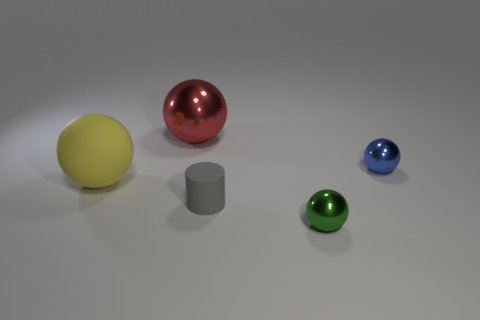Are there fewer green objects that are left of the large red thing than metal cylinders?
Provide a short and direct response. No. Are the small green sphere and the thing that is right of the green shiny ball made of the same material?
Provide a short and direct response. Yes. Are there any small shiny balls in front of the large yellow rubber ball behind the object that is in front of the small matte cylinder?
Provide a short and direct response. Yes. There is a ball that is made of the same material as the small gray thing; what is its color?
Keep it short and to the point. Yellow. There is a thing that is on the left side of the gray rubber cylinder and in front of the large red thing; how big is it?
Provide a succinct answer. Large. Is the number of large matte objects that are behind the small blue object less than the number of metallic objects on the right side of the small gray thing?
Provide a short and direct response. Yes. Is the material of the large object that is behind the large yellow ball the same as the small ball that is behind the small green ball?
Keep it short and to the point. Yes. The object that is both right of the small gray object and behind the small matte object has what shape?
Offer a very short reply. Sphere. What is the material of the sphere that is behind the small shiny sphere behind the tiny green shiny ball?
Give a very brief answer. Metal. Is the number of green cylinders greater than the number of yellow spheres?
Provide a succinct answer. No. 